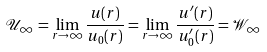Convert formula to latex. <formula><loc_0><loc_0><loc_500><loc_500>\mathcal { U } _ { \infty } = \lim _ { r \to \infty } \frac { u ( r ) } { u _ { 0 } ( r ) } = \lim _ { r \to \infty } \frac { u ^ { \prime } ( r ) } { u _ { 0 } ^ { \prime } ( r ) } = \mathcal { W } _ { \infty }</formula> 